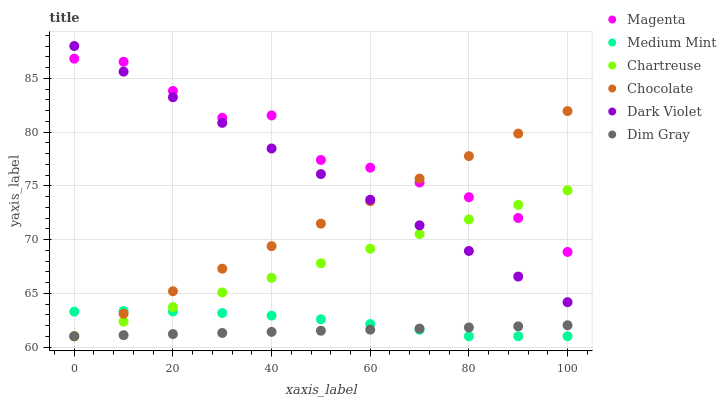Does Dim Gray have the minimum area under the curve?
Answer yes or no. Yes. Does Magenta have the maximum area under the curve?
Answer yes or no. Yes. Does Dark Violet have the minimum area under the curve?
Answer yes or no. No. Does Dark Violet have the maximum area under the curve?
Answer yes or no. No. Is Dark Violet the smoothest?
Answer yes or no. Yes. Is Magenta the roughest?
Answer yes or no. Yes. Is Dim Gray the smoothest?
Answer yes or no. No. Is Dim Gray the roughest?
Answer yes or no. No. Does Medium Mint have the lowest value?
Answer yes or no. Yes. Does Dark Violet have the lowest value?
Answer yes or no. No. Does Dark Violet have the highest value?
Answer yes or no. Yes. Does Dim Gray have the highest value?
Answer yes or no. No. Is Dim Gray less than Dark Violet?
Answer yes or no. Yes. Is Dark Violet greater than Dim Gray?
Answer yes or no. Yes. Does Dim Gray intersect Chartreuse?
Answer yes or no. Yes. Is Dim Gray less than Chartreuse?
Answer yes or no. No. Is Dim Gray greater than Chartreuse?
Answer yes or no. No. Does Dim Gray intersect Dark Violet?
Answer yes or no. No. 